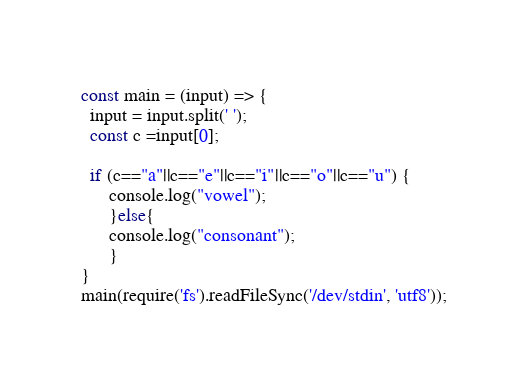<code> <loc_0><loc_0><loc_500><loc_500><_TypeScript_>const main = (input) => {
  input = input.split(' ');
  const c =input[0];
  
  if (c=="a"||c=="e"||c=="i"||c=="o"||c=="u") {
      console.log("vowel");
      }else{
      console.log("consonant");
      }
}
main(require('fs').readFileSync('/dev/stdin', 'utf8'));</code> 